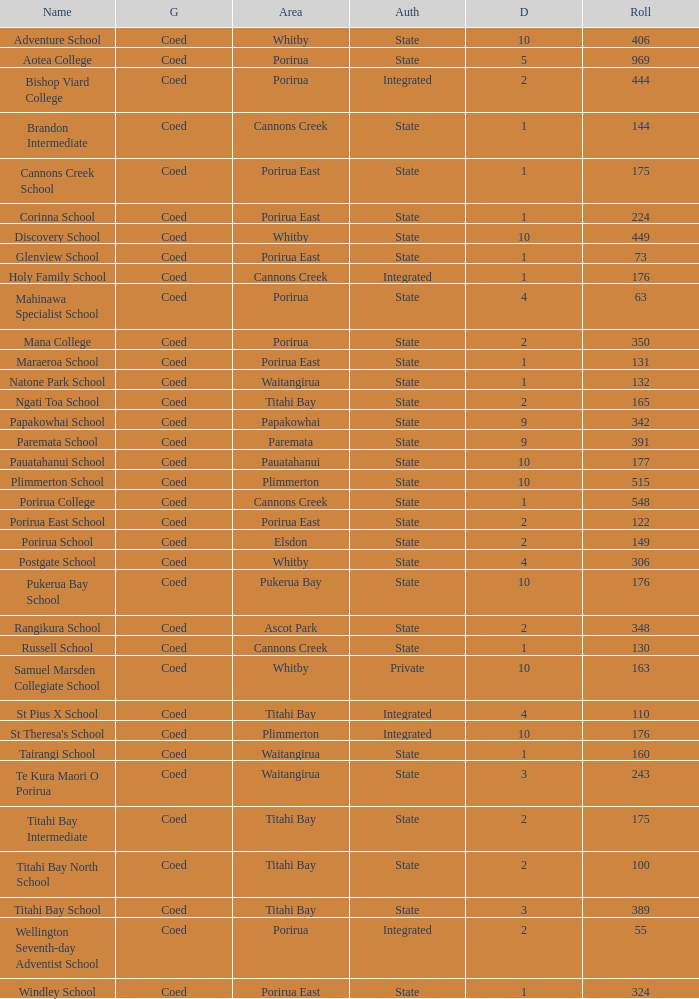What integrated school had a decile of 2 and a roll larger than 55? Bishop Viard College. 